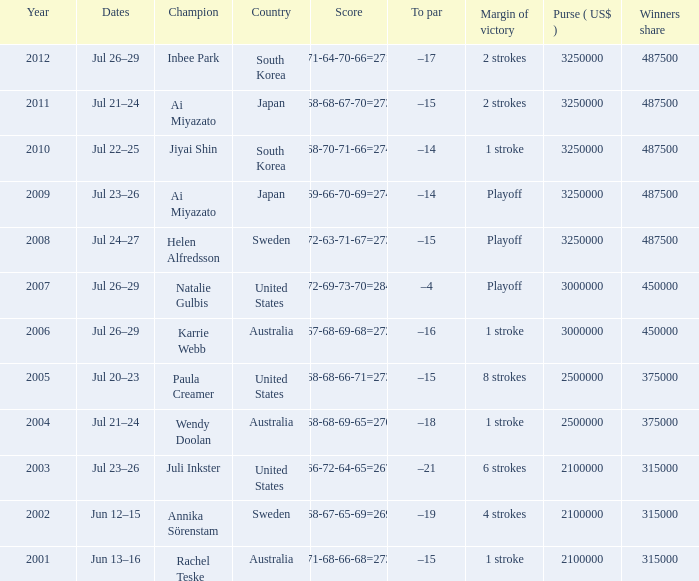What is the earliest year indicated? 2001.0. 